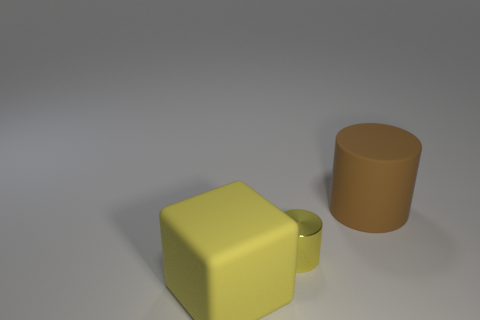Add 3 large red things. How many objects exist? 6 Subtract all cylinders. How many objects are left? 1 Add 3 yellow shiny things. How many yellow shiny things exist? 4 Subtract 0 gray balls. How many objects are left? 3 Subtract all blue matte cylinders. Subtract all big brown rubber cylinders. How many objects are left? 2 Add 3 large yellow rubber blocks. How many large yellow rubber blocks are left? 4 